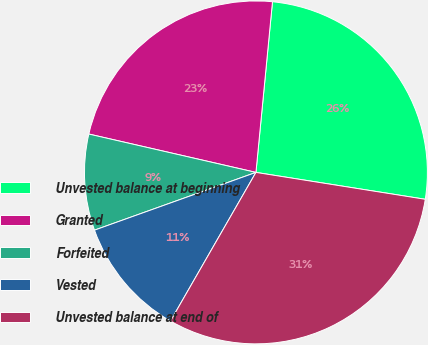Convert chart to OTSL. <chart><loc_0><loc_0><loc_500><loc_500><pie_chart><fcel>Unvested balance at beginning<fcel>Granted<fcel>Forfeited<fcel>Vested<fcel>Unvested balance at end of<nl><fcel>25.97%<fcel>22.95%<fcel>9.06%<fcel>11.23%<fcel>30.8%<nl></chart> 